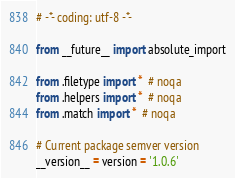<code> <loc_0><loc_0><loc_500><loc_500><_Python_># -*- coding: utf-8 -*-

from __future__ import absolute_import

from .filetype import *  # noqa
from .helpers import *  # noqa
from .match import *  # noqa

# Current package semver version
__version__ = version = '1.0.6'
</code> 